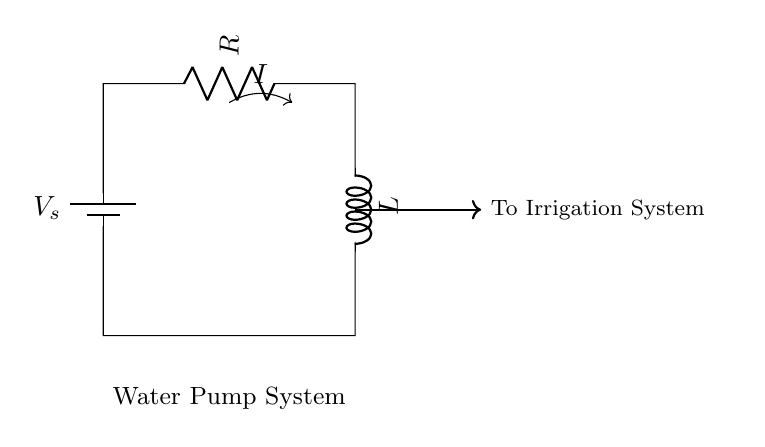What is the current in the circuit? The current \( I \) flows from the battery through the resistor and inductor, creating a loop. The circuit does not specify a numerical value for \( I \), but it represents the flow of electric charge necessary for the pump operation.
Answer: Current What components are used in this circuit? The circuit consists of a battery (voltage source), a resistor (R), and an inductor (L). Each of these components plays a role in regulating the current for the water pump system.
Answer: Battery, resistor, inductor What role does the resistor play in this circuit? The resistor limits the amount of current that can flow through the circuit. This is essential for protecting the components, including the water pump, from excessive current that can cause damage.
Answer: Limits current What is the primary function of the inductor in this circuit? The inductor stores energy in a magnetic field when the current passes through it and releases that energy when the current decreases. This is crucial for providing a steady flow of current to the water pump by smoothing out fluctuations.
Answer: Stores energy How does the water pump connect to the circuit? The water pump is powered by the current flowing through the circuit, which is directed to the irrigation system. This connection is indicated by the arrow and label in the diagram showing the flow from the circuit to the irrigation system.
Answer: To irrigation system What might happen if the resistor's value is too low? A low resistor value will allow a high current to flow, which can lead to overheating and damage to the components, including the water pump. It could also cause excessive power consumption, leading to inefficiency in the system.
Answer: Overheating 